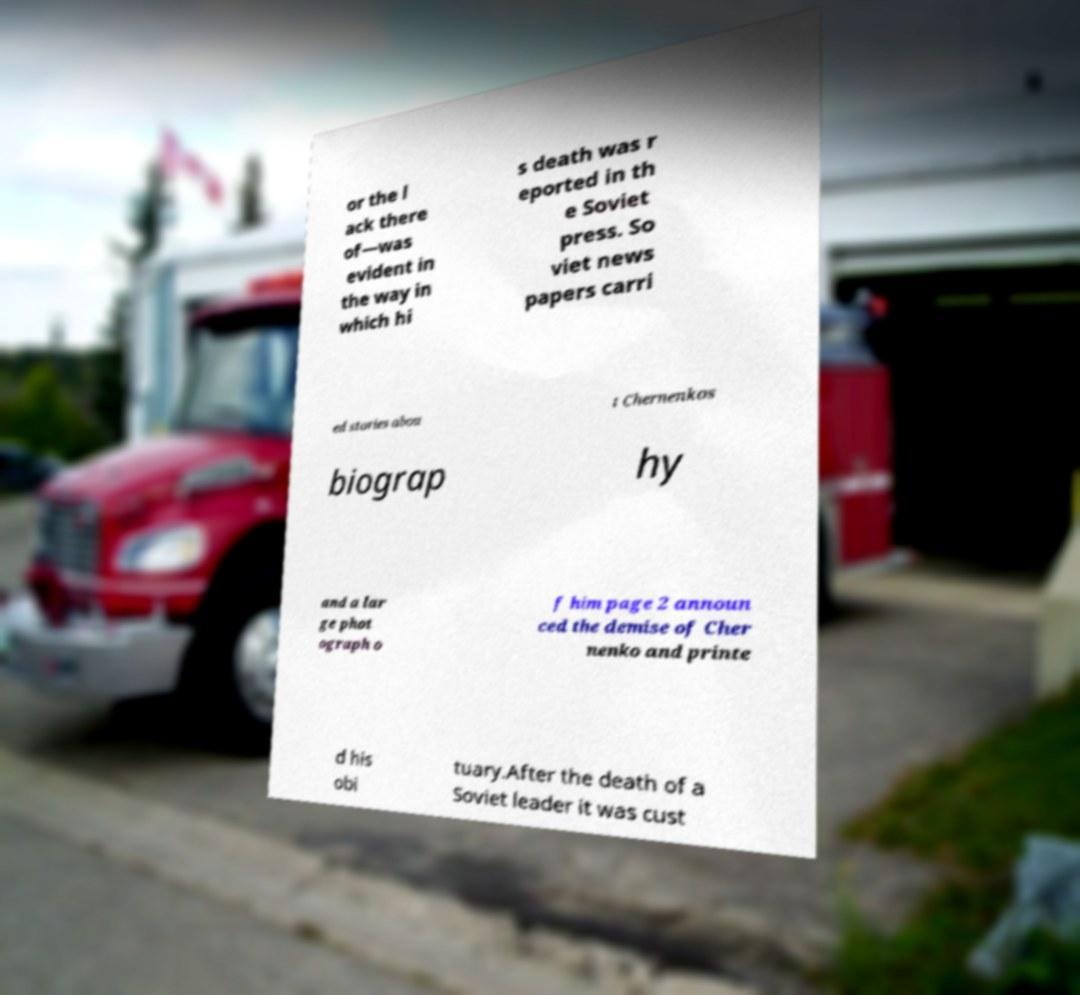Can you accurately transcribe the text from the provided image for me? or the l ack there of—was evident in the way in which hi s death was r eported in th e Soviet press. So viet news papers carri ed stories abou t Chernenkos biograp hy and a lar ge phot ograph o f him page 2 announ ced the demise of Cher nenko and printe d his obi tuary.After the death of a Soviet leader it was cust 